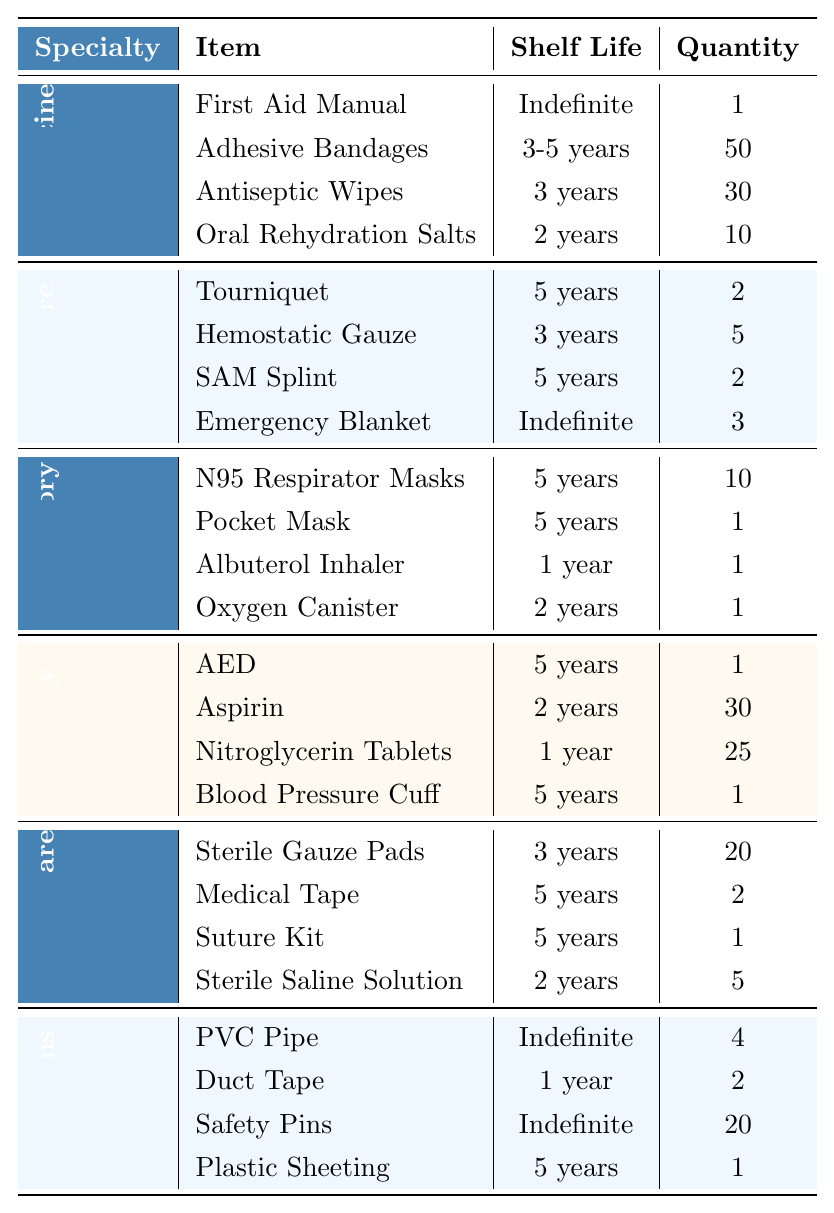What is the total quantity of Adhesive Bandages in the kit? The table shows that there are 50 Adhesive Bandages listed under General Medicine specialty. Therefore, the total quantity is simply the amount indicated in that row.
Answer: 50 Which item has the longest shelf life in Trauma Care? In the Trauma Care section, the Emergency Blanket and Tourniquet have an indefinite shelf life. Therefore, they are the items with the longest shelf life.
Answer: Emergency Blanket, Tourniquet Is there an item in the DIY Modifications section with a shelf life of more than 5 years? Reviewing the DIY Modifications section, all items either have an indefinite shelf life or a maximum shelf life of 5 years. Therefore, there is no item with a shelf life exceeding 5 years.
Answer: No How many items in the inventory have a shelf life of 1 year? The inventory shows two items with a shelf life of 1 year: the Albuterol Inhaler and Duct Tape. By counting these entries, we find there are 2 items.
Answer: 2 What is the total quantity of shelf life items listed under Respiratory? Adding the quantities of items listed under Respiratory: N95 Respirator Masks (10) + Pocket Mask (1) + Albuterol Inhaler (1) + Oxygen Canister (1) equals a total of 13 items.
Answer: 13 Which specialty has the highest total quantity of items? Analyzing the total quantities per specialty: General Medicine (91), Trauma Care (10), Respiratory (12), Cardiology (57), Wound Care (28), DIY Modifications (27). General Medicine has the highest total quantity of 91 items.
Answer: General Medicine Are there more items with an indefinite shelf life or those with a shelf life of 1 year? The indefinite shelf life items counted: First Aid Manual, Emergency Blanket, PVC Pipe, Safety Pins (total of 4). For 1 year, there are Albuterol Inhaler and Duct Tape (total of 2). Hence, there are more items with indefinite shelf life.
Answer: Indefinite shelf life What is the average shelf life of all items in the Wound Care category? The Wound Care items have shelf lives of 3 years, 5 years, 5 years, and 2 years. Converting these into numerical values gives us: 3, 5, 5, and 2. Summing them: 3+5+5+2=15. There are 4 items, so the average shelf life is 15/4 = 3.75 years.
Answer: 3.75 years Which specialty has the least quantity of items, and what is the quantity? Counting item quantities reveals Trauma Care has 10 items, which is the least among all specialties.
Answer: Trauma Care, 10 Is there any cardiology item that has a shelf life longer than 2 years? In the Cardiology section, the AED, Blood Pressure Cuff, and Aspirin all have shelf lives greater than 2 years (5 years for AED and Blood Pressure Cuff; 2 years for Aspirin). Therefore, yes, there are items with longer shelf lives.
Answer: Yes If we combine the quantities of items with a shelf life less than 2 years from all categories, what do we get? The items with less than 2 years shelf life are Albuterol Inhaler (1), Nitroglycerin Tablets (25), Duct Tape (2). Adding these items gives: 1 + 25 + 2 = 28 total items.
Answer: 28 